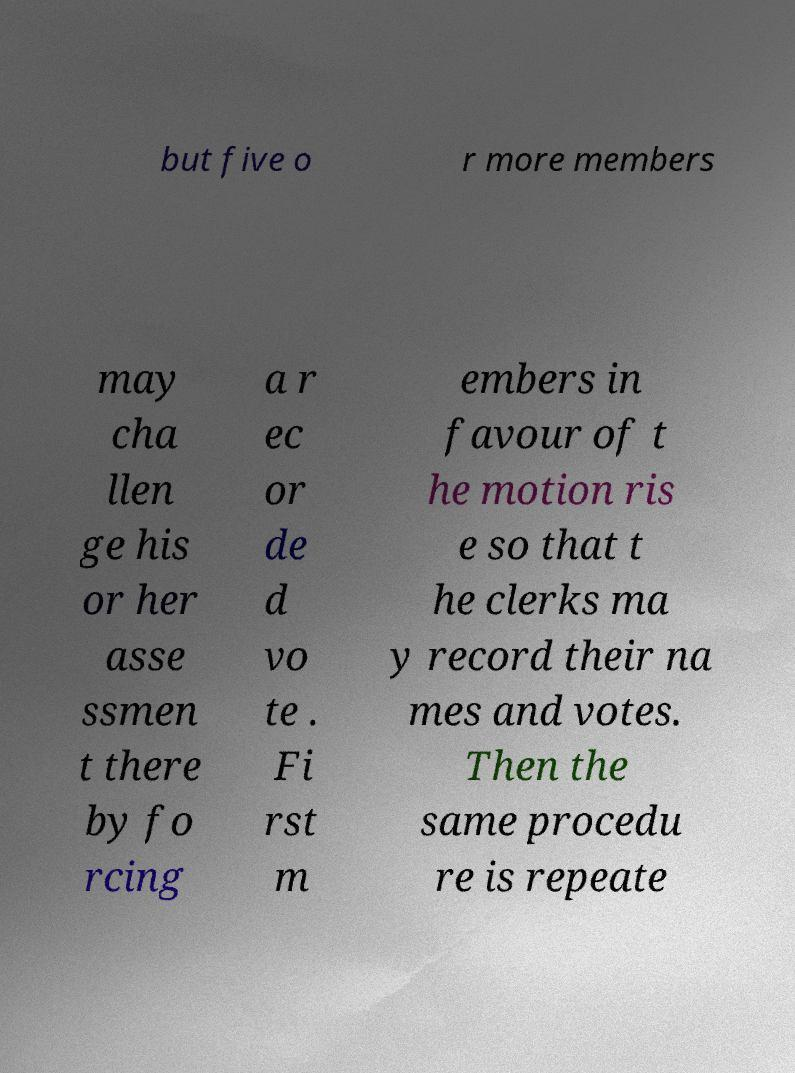Could you extract and type out the text from this image? but five o r more members may cha llen ge his or her asse ssmen t there by fo rcing a r ec or de d vo te . Fi rst m embers in favour of t he motion ris e so that t he clerks ma y record their na mes and votes. Then the same procedu re is repeate 